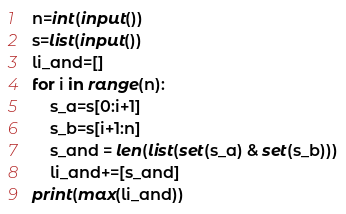<code> <loc_0><loc_0><loc_500><loc_500><_Python_>n=int(input())
s=list(input())
li_and=[]
for i in range(n):
    s_a=s[0:i+1]
    s_b=s[i+1:n]
    s_and = len(list(set(s_a) & set(s_b)))
    li_and+=[s_and]
print(max(li_and))</code> 